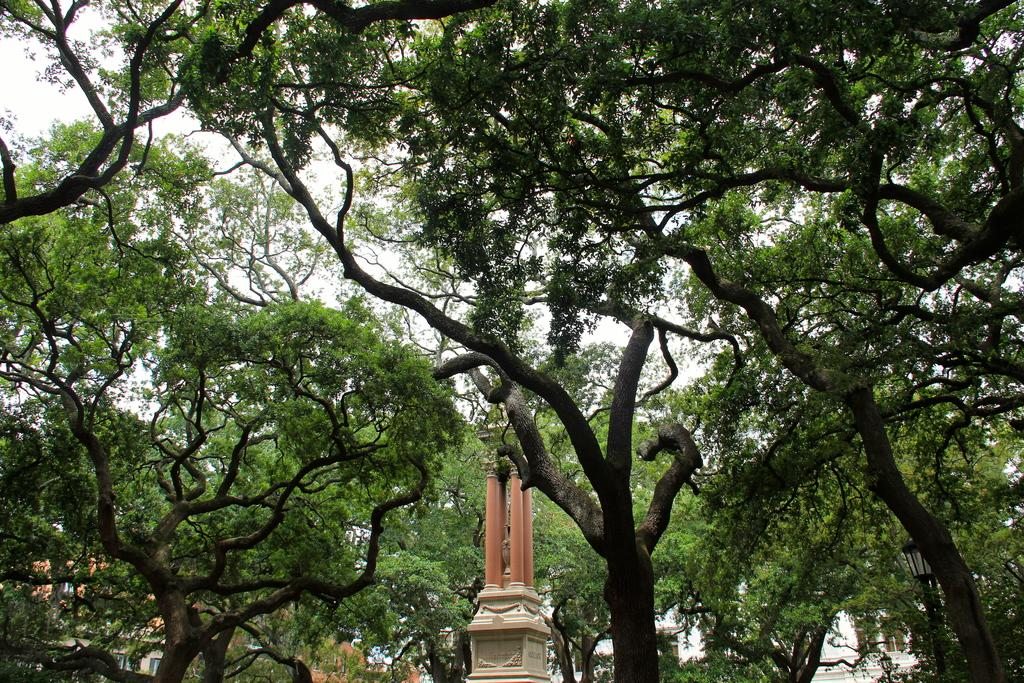What is the main subject in the center of the image? There is a memorial in the center of the image. What can be seen in the background of the image? There are trees, the sky, and buildings visible in the background of the image. Where is the light pole located in the image? The light pole is on the right side of the image. How does the wish come true in the image? There is no mention of a wish in the image; it features a memorial and other elements. What type of yard is visible in the image? There is no yard present in the image. 